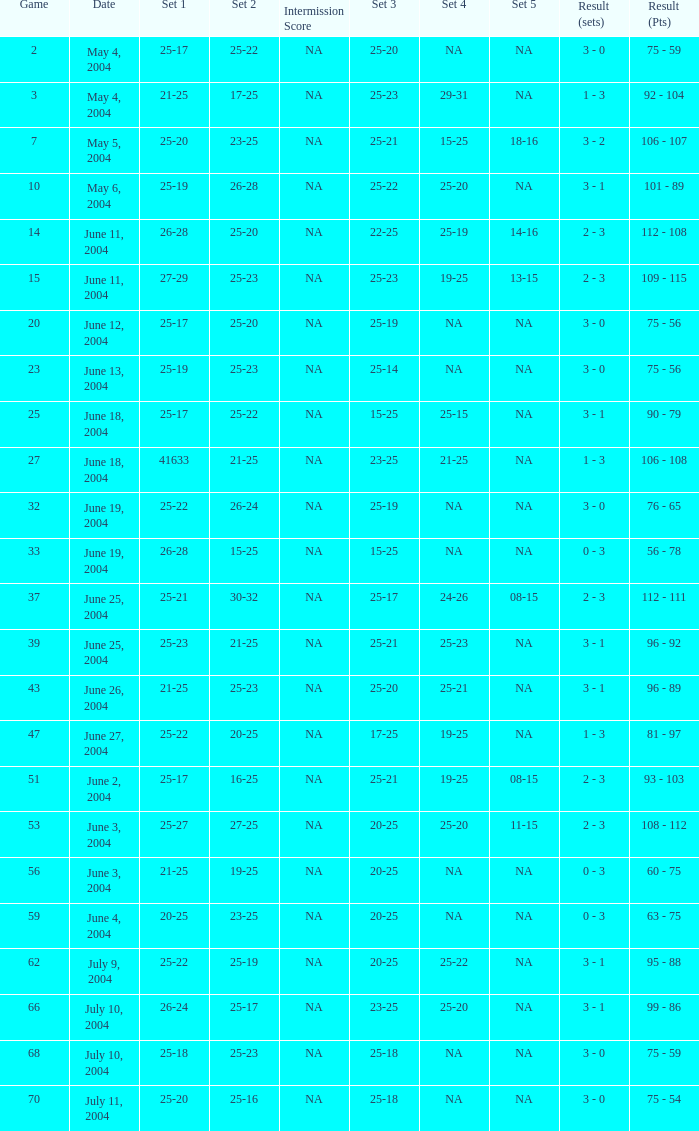What is the set 5 for the game with a set 2 of 21-25 and a set 1 of 41633? NA. 